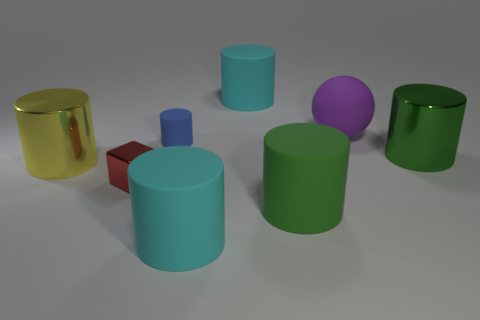Subtract all green rubber cylinders. How many cylinders are left? 5 Subtract all cyan cubes. How many green cylinders are left? 2 Subtract 4 cylinders. How many cylinders are left? 2 Subtract all green cylinders. How many cylinders are left? 4 Add 1 gray cubes. How many objects exist? 9 Subtract all yellow cylinders. Subtract all cyan blocks. How many cylinders are left? 5 Subtract all cubes. How many objects are left? 7 Subtract 2 green cylinders. How many objects are left? 6 Subtract all big green shiny things. Subtract all tiny blue rubber cylinders. How many objects are left? 6 Add 7 tiny blue things. How many tiny blue things are left? 8 